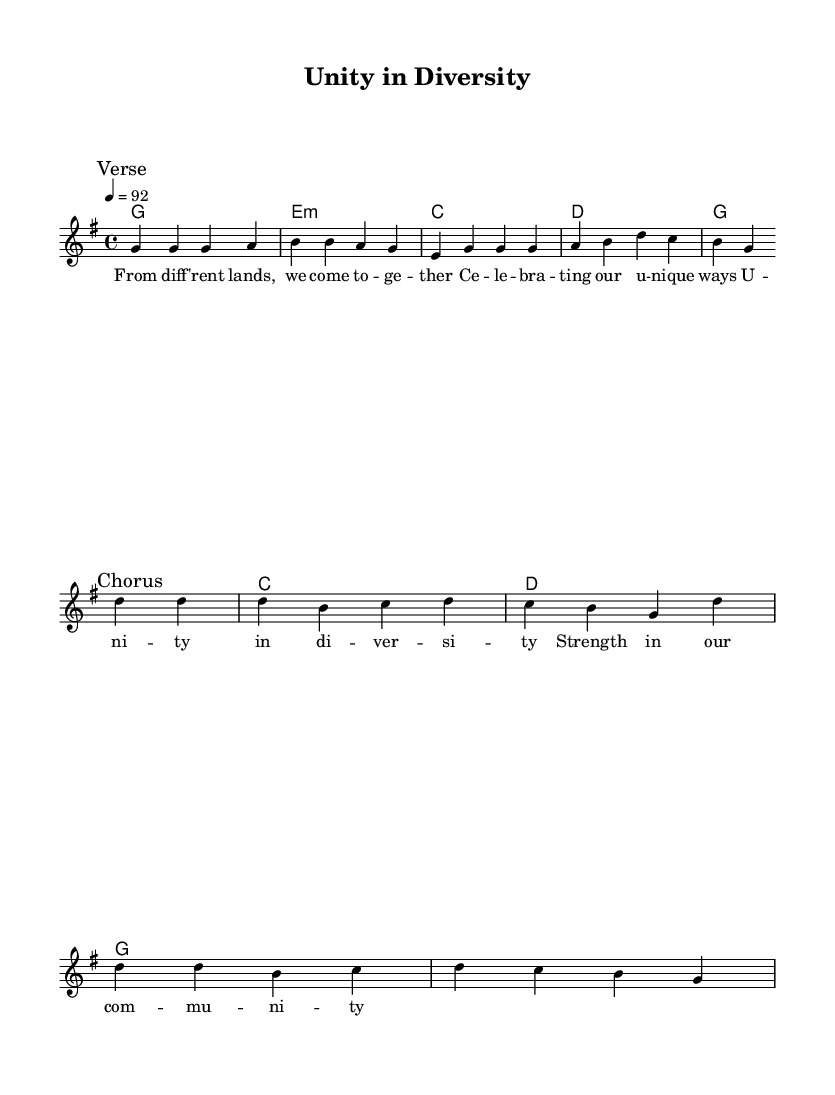What is the key signature of this music? The key signature is G major, which has one sharp (F#). This is indicated at the beginning of the sheet music.
Answer: G major What is the time signature of this music? The time signature is 4/4, which means there are four beats in each measure and the quarter note gets one beat. This is shown at the beginning of the score next to the key signature.
Answer: 4/4 What is the tempo marking for this piece? The tempo marking is 92 beats per minute, which is indicated above the staff. This suggests a moderate pace for the performance of the music.
Answer: 92 What is the first lyric line of the verse? The first lyric line of the verse states "From different lands, we come together." This is the starting line included in the lyrics section under the melody.
Answer: From different lands, we come together Which chord follows the melody in the chorus? The chord that follows the melody in the chorus is C major. This can be determined by looking at the chord symbols written above the staff during the chorus section.
Answer: C How many measures are in the chorus section? There are four measures in the chorus section, as indicated by the four bars that contain musical notes and corresponding chords. This can be counted by viewing the notes and lines under the "Chorus" mark.
Answer: 4 What is the overall message reflected in the lyrics of this piece? The overall message reflects unity and strength in diversity, emphasizing the celebration of different cultures and community empowerment as indicated in the lyrics.
Answer: Unity in diversity 